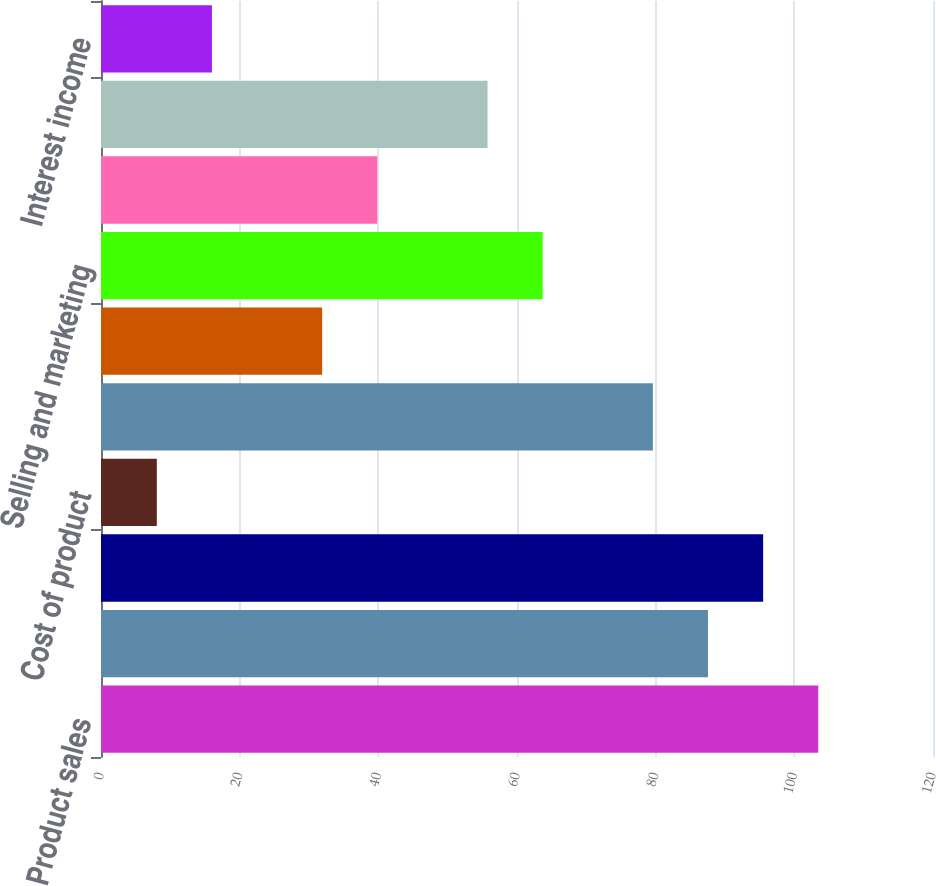Convert chart. <chart><loc_0><loc_0><loc_500><loc_500><bar_chart><fcel>Product sales<fcel>Service and other revenue<fcel>Cost of product sales<fcel>Cost of product<fcel>Cost of service and other<fcel>Research and development<fcel>Selling and marketing<fcel>General and administrative<fcel>Income from operations<fcel>Interest income<nl><fcel>103.45<fcel>87.55<fcel>95.5<fcel>8.05<fcel>79.6<fcel>31.9<fcel>63.7<fcel>39.85<fcel>55.75<fcel>16<nl></chart> 